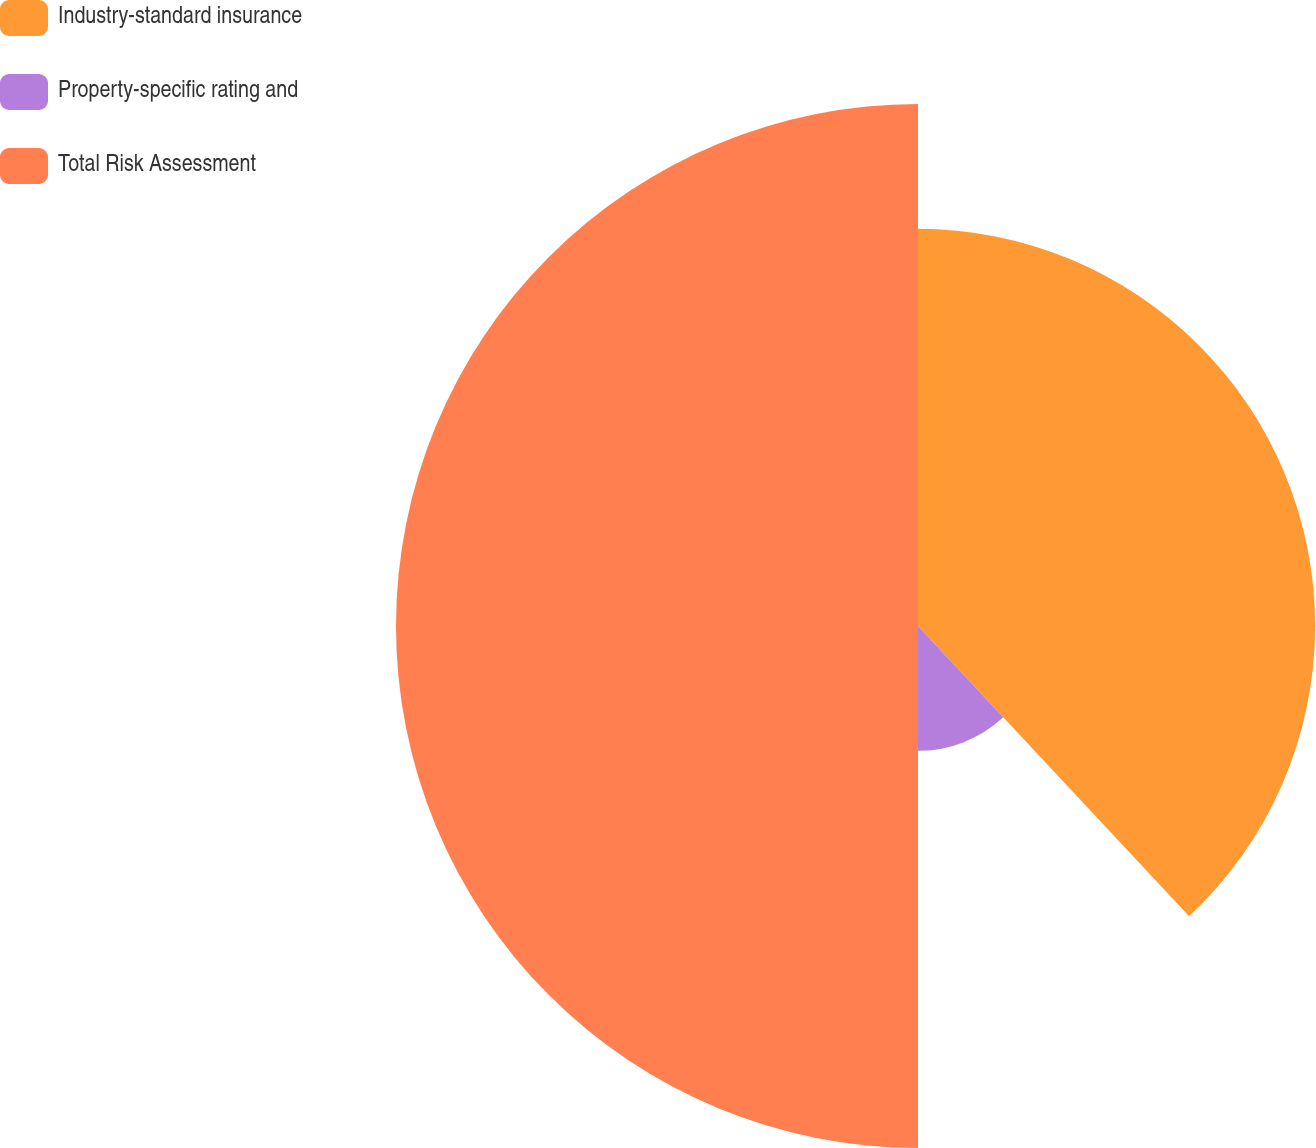Convert chart to OTSL. <chart><loc_0><loc_0><loc_500><loc_500><pie_chart><fcel>Industry-standard insurance<fcel>Property-specific rating and<fcel>Total Risk Assessment<nl><fcel>38.04%<fcel>11.96%<fcel>50.0%<nl></chart> 